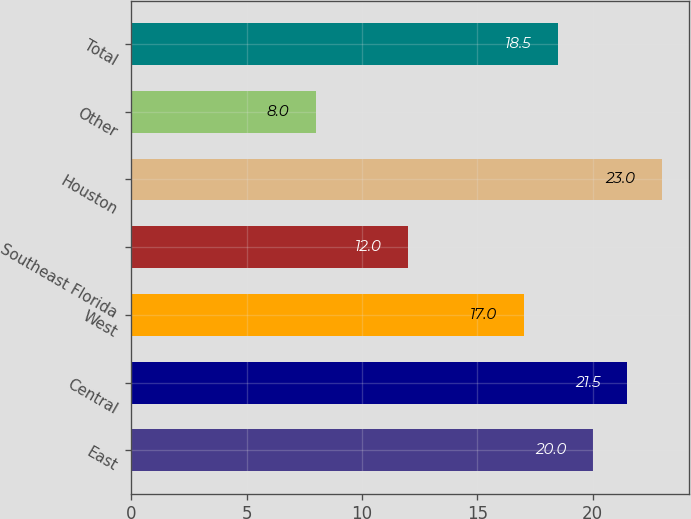Convert chart to OTSL. <chart><loc_0><loc_0><loc_500><loc_500><bar_chart><fcel>East<fcel>Central<fcel>West<fcel>Southeast Florida<fcel>Houston<fcel>Other<fcel>Total<nl><fcel>20<fcel>21.5<fcel>17<fcel>12<fcel>23<fcel>8<fcel>18.5<nl></chart> 